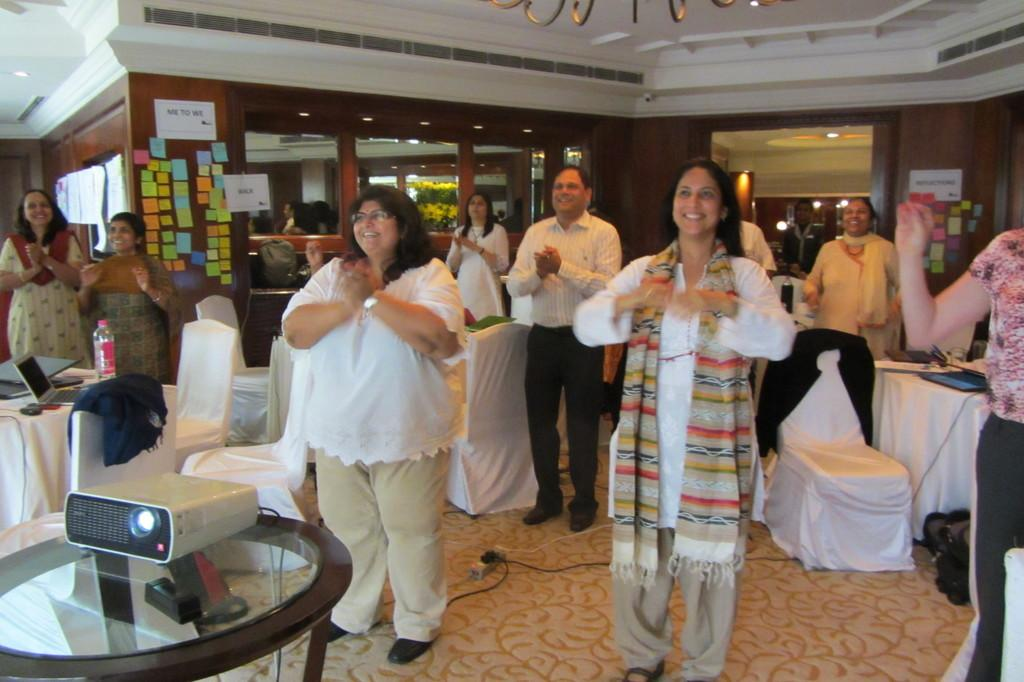What are the people in the image doing? The people in the image are standing and clapping. What is the facial expression of the people in the image? The people in the image are smiling. What can be seen on the wall in the background of the image? There are papers placed on the wall in the background. What type of furniture is present in the image? There are tables and chairs in the image. Can you see a crib in the image? No, there is no crib present in the image. What type of cloud is visible in the image? There are no clouds visible in the image, as it is an indoor scene. 